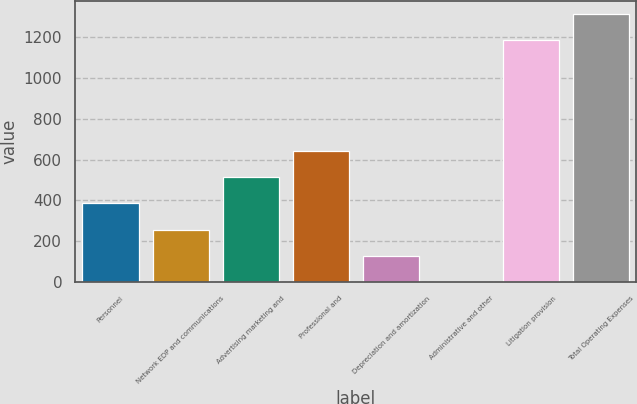Convert chart to OTSL. <chart><loc_0><loc_0><loc_500><loc_500><bar_chart><fcel>Personnel<fcel>Network EDP and communications<fcel>Advertising marketing and<fcel>Professional and<fcel>Depreciation and amortization<fcel>Administrative and other<fcel>Litigation provision<fcel>Total Operating Expenses<nl><fcel>384.8<fcel>257.2<fcel>512.4<fcel>640<fcel>129.6<fcel>2<fcel>1183<fcel>1310.6<nl></chart> 